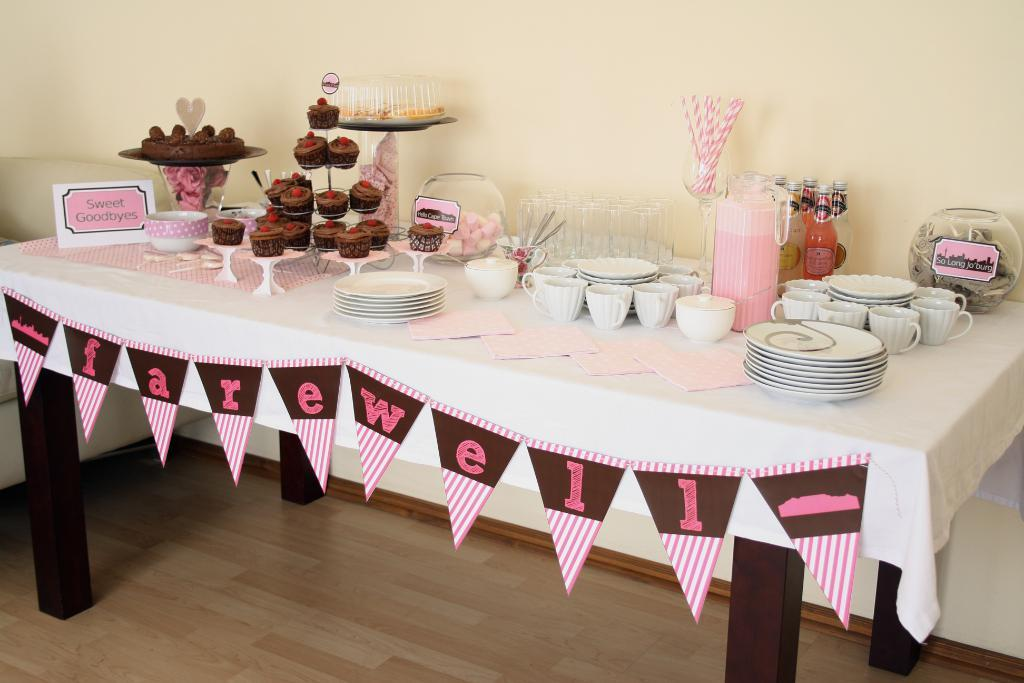What is located in the foreground of the image? There is a table in the foreground of the image. What items can be seen on the table? Cups, plates, cupcakes, a bowl, and bottles are on the table. What type of room is the image taken in? The image is taken in a room. What can be seen in the background of the image? There is a wall visible in the background of the image. What type of underwear is the governor wearing in the image? There is no governor or underwear present in the image. Can you perform magic with the cupcakes on the table? The image does not depict any magic or magical abilities, and the cupcakes are not shown to have any magical properties. 